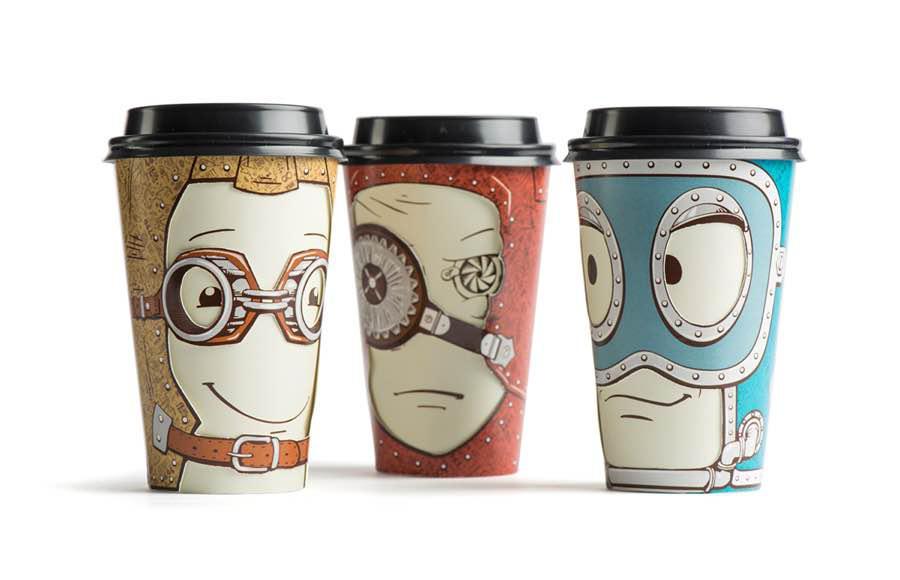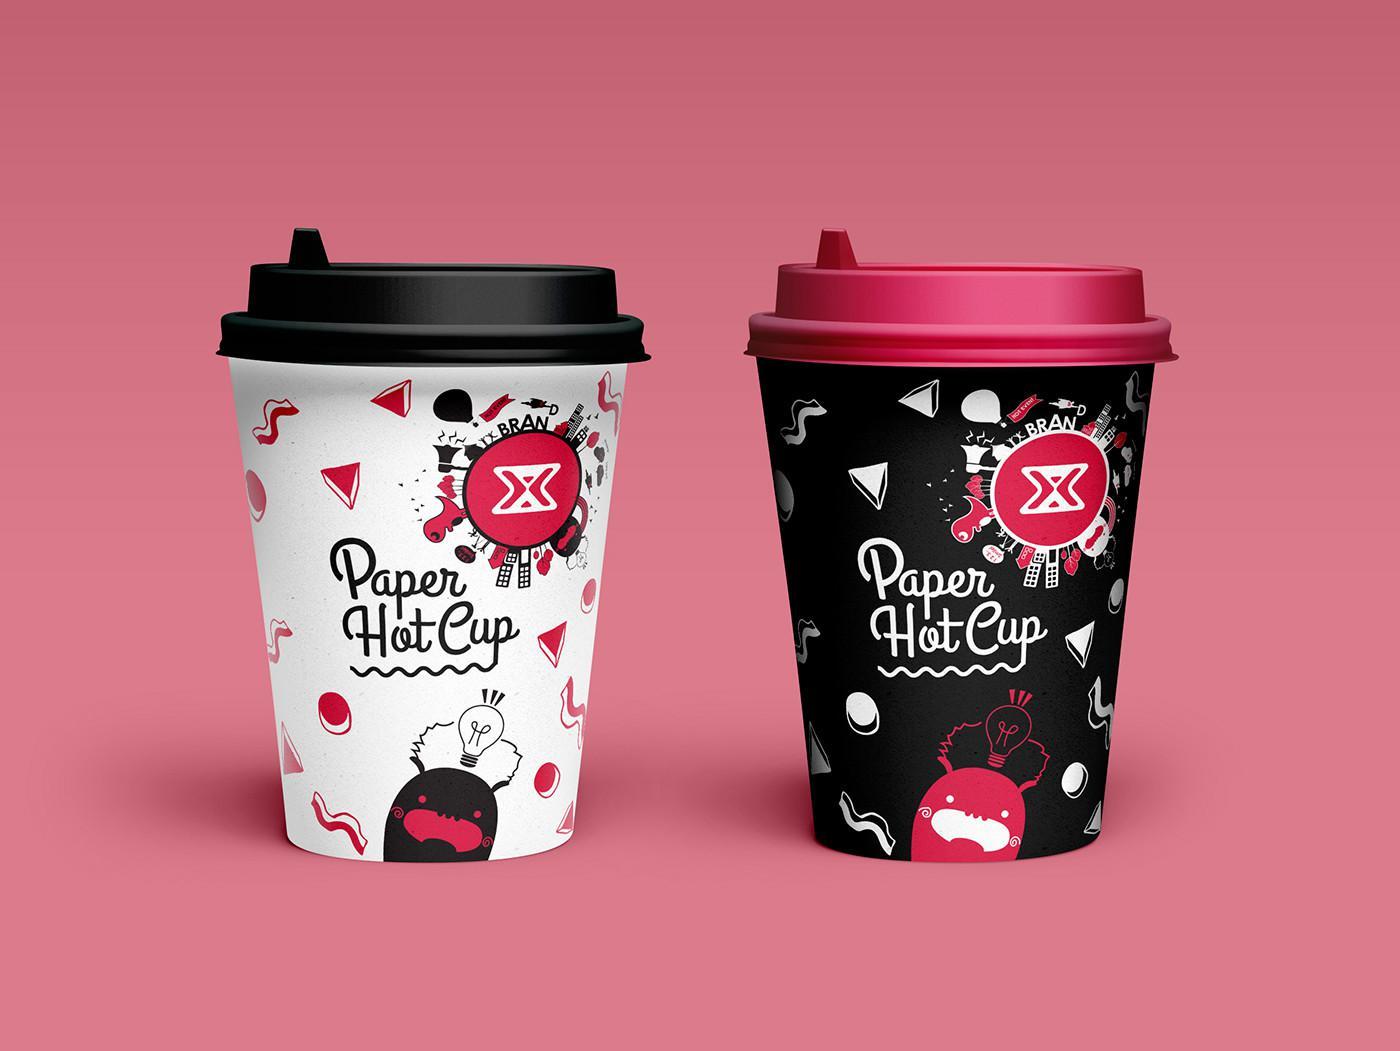The first image is the image on the left, the second image is the image on the right. For the images shown, is this caption "There are five coffee cups." true? Answer yes or no. Yes. The first image is the image on the left, the second image is the image on the right. For the images shown, is this caption "There are exactly five cups." true? Answer yes or no. Yes. 